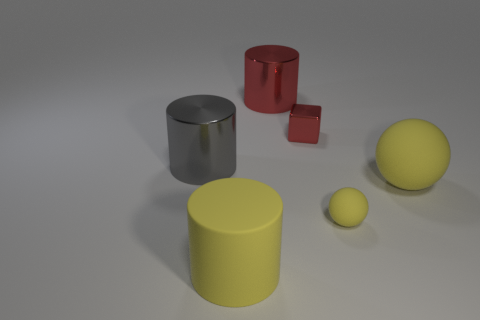Add 4 tiny yellow matte blocks. How many objects exist? 10 Subtract all cubes. How many objects are left? 5 Subtract 1 red cylinders. How many objects are left? 5 Subtract all big gray cylinders. Subtract all big red things. How many objects are left? 4 Add 3 yellow balls. How many yellow balls are left? 5 Add 1 metal cubes. How many metal cubes exist? 2 